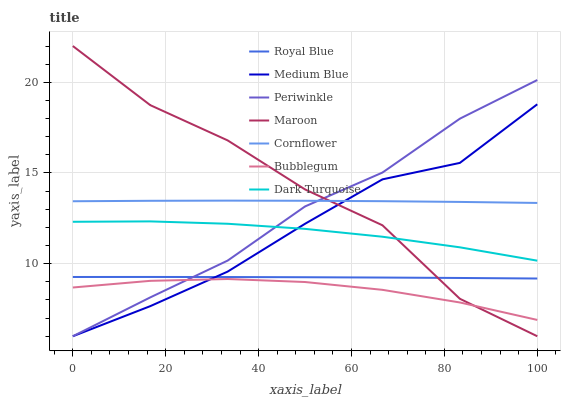Does Bubblegum have the minimum area under the curve?
Answer yes or no. Yes. Does Maroon have the maximum area under the curve?
Answer yes or no. Yes. Does Dark Turquoise have the minimum area under the curve?
Answer yes or no. No. Does Dark Turquoise have the maximum area under the curve?
Answer yes or no. No. Is Royal Blue the smoothest?
Answer yes or no. Yes. Is Maroon the roughest?
Answer yes or no. Yes. Is Dark Turquoise the smoothest?
Answer yes or no. No. Is Dark Turquoise the roughest?
Answer yes or no. No. Does Medium Blue have the lowest value?
Answer yes or no. Yes. Does Dark Turquoise have the lowest value?
Answer yes or no. No. Does Maroon have the highest value?
Answer yes or no. Yes. Does Dark Turquoise have the highest value?
Answer yes or no. No. Is Bubblegum less than Cornflower?
Answer yes or no. Yes. Is Cornflower greater than Dark Turquoise?
Answer yes or no. Yes. Does Maroon intersect Periwinkle?
Answer yes or no. Yes. Is Maroon less than Periwinkle?
Answer yes or no. No. Is Maroon greater than Periwinkle?
Answer yes or no. No. Does Bubblegum intersect Cornflower?
Answer yes or no. No. 